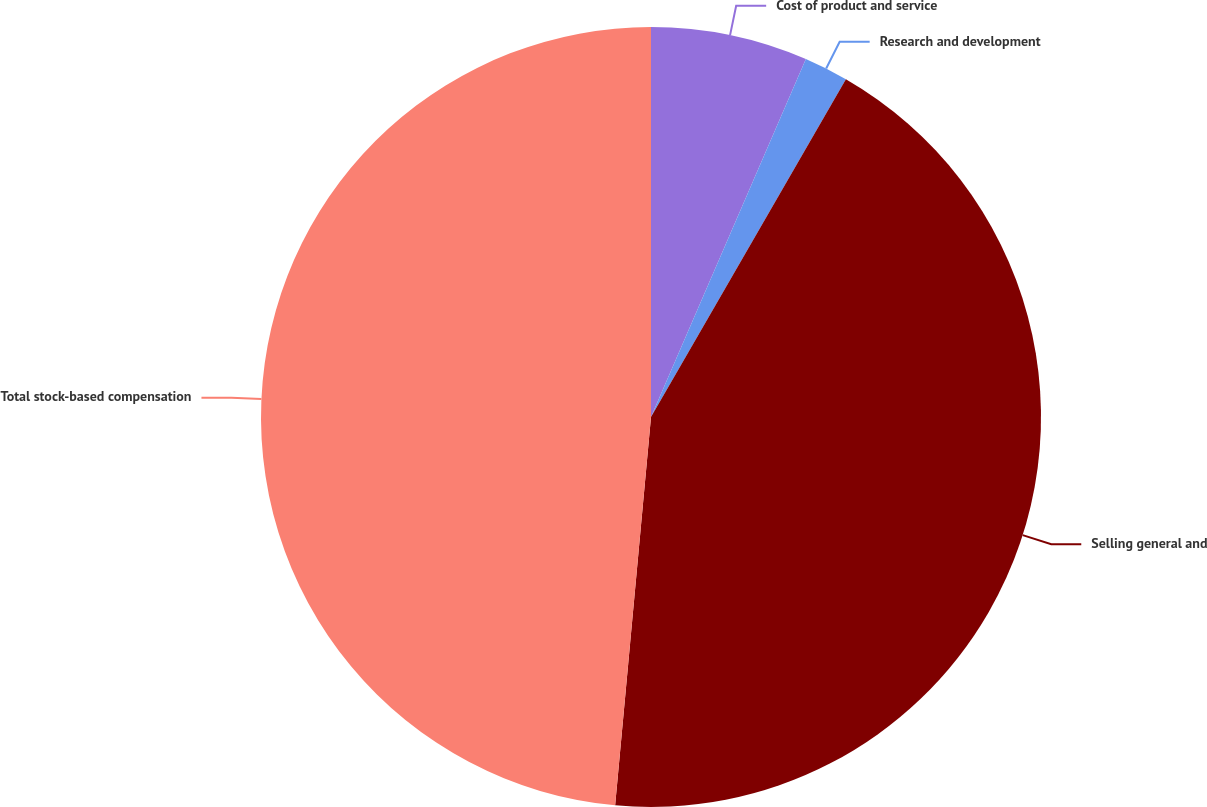Convert chart to OTSL. <chart><loc_0><loc_0><loc_500><loc_500><pie_chart><fcel>Cost of product and service<fcel>Research and development<fcel>Selling general and<fcel>Total stock-based compensation<nl><fcel>6.5%<fcel>1.83%<fcel>43.14%<fcel>48.54%<nl></chart> 